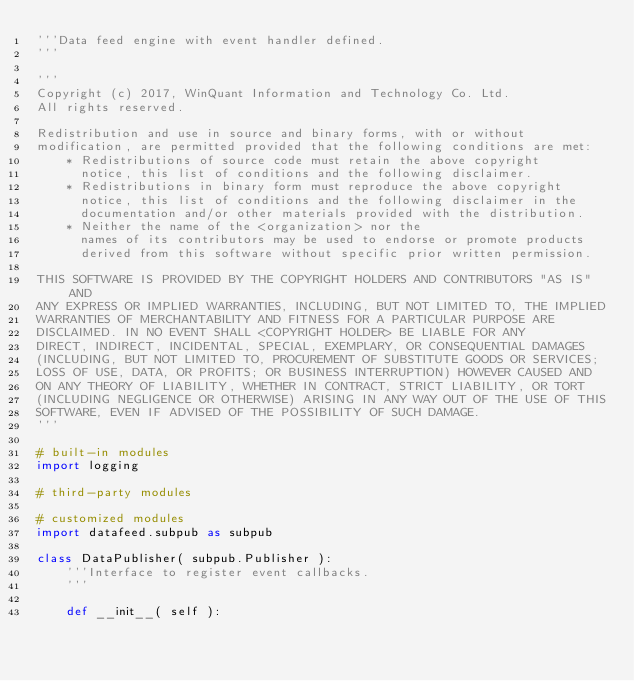<code> <loc_0><loc_0><loc_500><loc_500><_Python_>'''Data feed engine with event handler defined.
'''

'''
Copyright (c) 2017, WinQuant Information and Technology Co. Ltd.
All rights reserved.

Redistribution and use in source and binary forms, with or without
modification, are permitted provided that the following conditions are met:
    * Redistributions of source code must retain the above copyright
      notice, this list of conditions and the following disclaimer.
    * Redistributions in binary form must reproduce the above copyright
      notice, this list of conditions and the following disclaimer in the
      documentation and/or other materials provided with the distribution.
    * Neither the name of the <organization> nor the
      names of its contributors may be used to endorse or promote products
      derived from this software without specific prior written permission.

THIS SOFTWARE IS PROVIDED BY THE COPYRIGHT HOLDERS AND CONTRIBUTORS "AS IS" AND
ANY EXPRESS OR IMPLIED WARRANTIES, INCLUDING, BUT NOT LIMITED TO, THE IMPLIED
WARRANTIES OF MERCHANTABILITY AND FITNESS FOR A PARTICULAR PURPOSE ARE
DISCLAIMED. IN NO EVENT SHALL <COPYRIGHT HOLDER> BE LIABLE FOR ANY
DIRECT, INDIRECT, INCIDENTAL, SPECIAL, EXEMPLARY, OR CONSEQUENTIAL DAMAGES
(INCLUDING, BUT NOT LIMITED TO, PROCUREMENT OF SUBSTITUTE GOODS OR SERVICES;
LOSS OF USE, DATA, OR PROFITS; OR BUSINESS INTERRUPTION) HOWEVER CAUSED AND
ON ANY THEORY OF LIABILITY, WHETHER IN CONTRACT, STRICT LIABILITY, OR TORT
(INCLUDING NEGLIGENCE OR OTHERWISE) ARISING IN ANY WAY OUT OF THE USE OF THIS
SOFTWARE, EVEN IF ADVISED OF THE POSSIBILITY OF SUCH DAMAGE.
'''

# built-in modules
import logging

# third-party modules

# customized modules
import datafeed.subpub as subpub

class DataPublisher( subpub.Publisher ):
    '''Interface to register event callbacks.
    '''

    def __init__( self ):</code> 